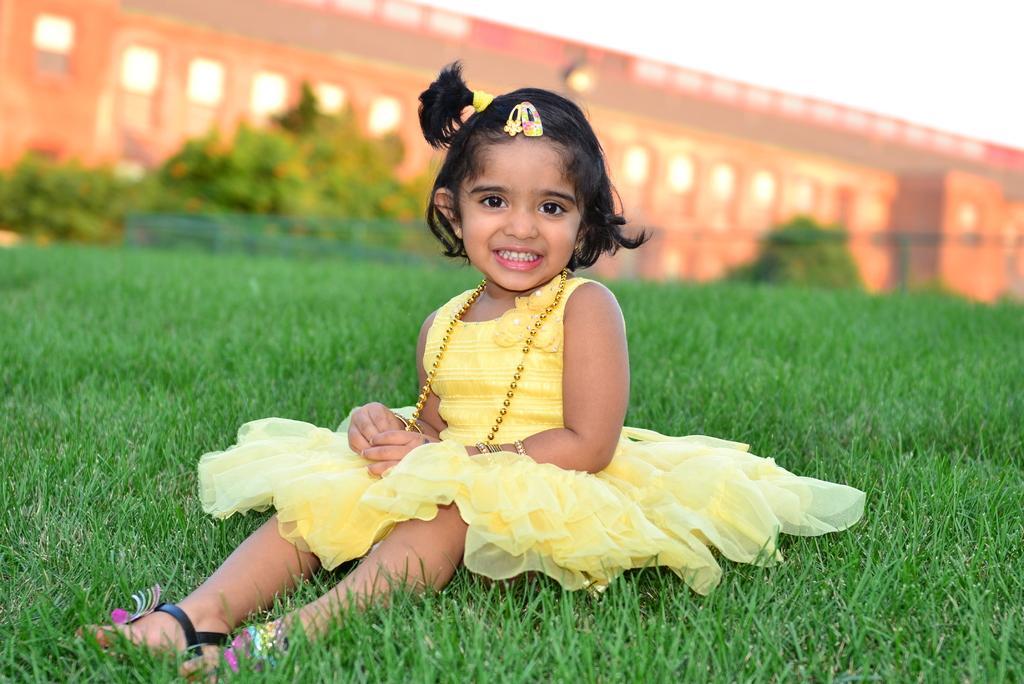In one or two sentences, can you explain what this image depicts? In this picture we can see a kid is sitting and smiling, at the bottom there is grass, in the background it looks like a building, there are some trees in the middle, there is the sky at the right top of the picture. 